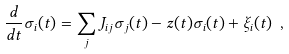Convert formula to latex. <formula><loc_0><loc_0><loc_500><loc_500>\frac { d } { d t } \sigma _ { i } ( t ) = \sum _ { j } J _ { i j } \sigma _ { j } ( t ) - z ( t ) \sigma _ { i } ( t ) + \xi _ { i } ( t ) \ ,</formula> 